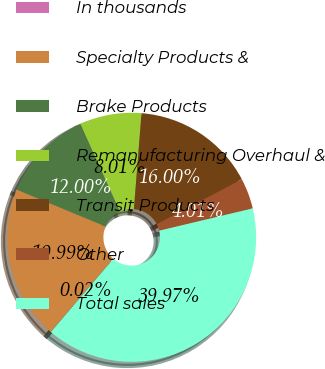Convert chart. <chart><loc_0><loc_0><loc_500><loc_500><pie_chart><fcel>In thousands<fcel>Specialty Products &<fcel>Brake Products<fcel>Remanufacturing Overhaul &<fcel>Transit Products<fcel>Other<fcel>Total sales<nl><fcel>0.02%<fcel>19.99%<fcel>12.0%<fcel>8.01%<fcel>16.0%<fcel>4.01%<fcel>39.97%<nl></chart> 